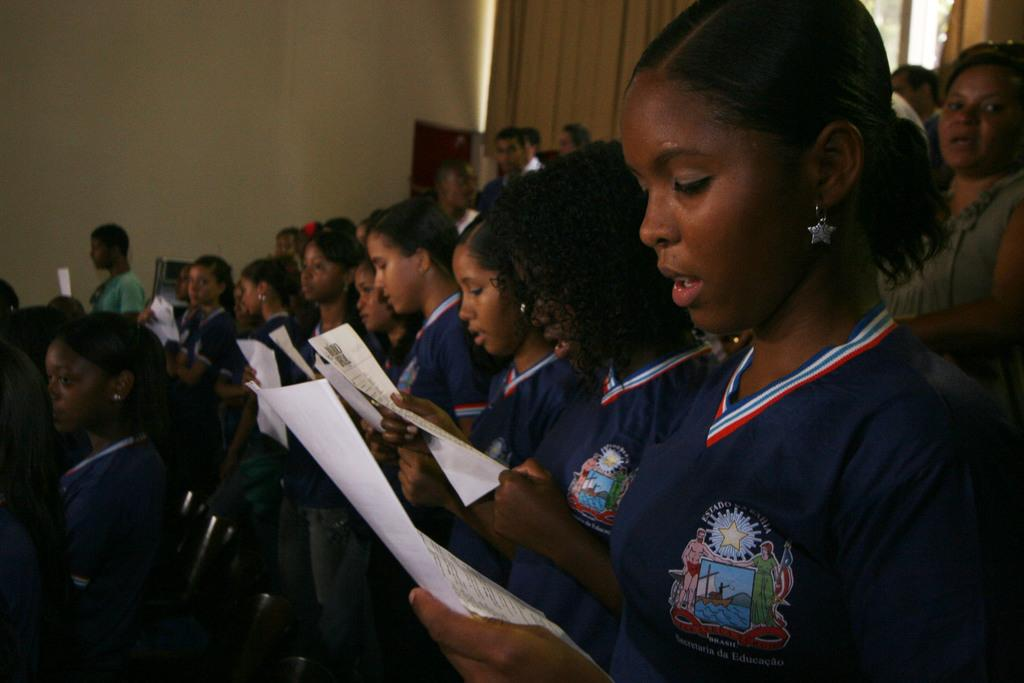How many people are in the image? There is a group of people in the image. What are the people doing in the image? The people are standing and holding papers. What can be observed about the people's clothing in the image? The people are wearing different color dresses. What is present in the background of the image? There is a wall in the image. Can you describe any other elements in the image? Yes, there are objects visible in the image. What type of needle can be seen in the image? There is no needle present in the image. What does the image smell like? Images do not have a smell, so this question cannot be answered. 